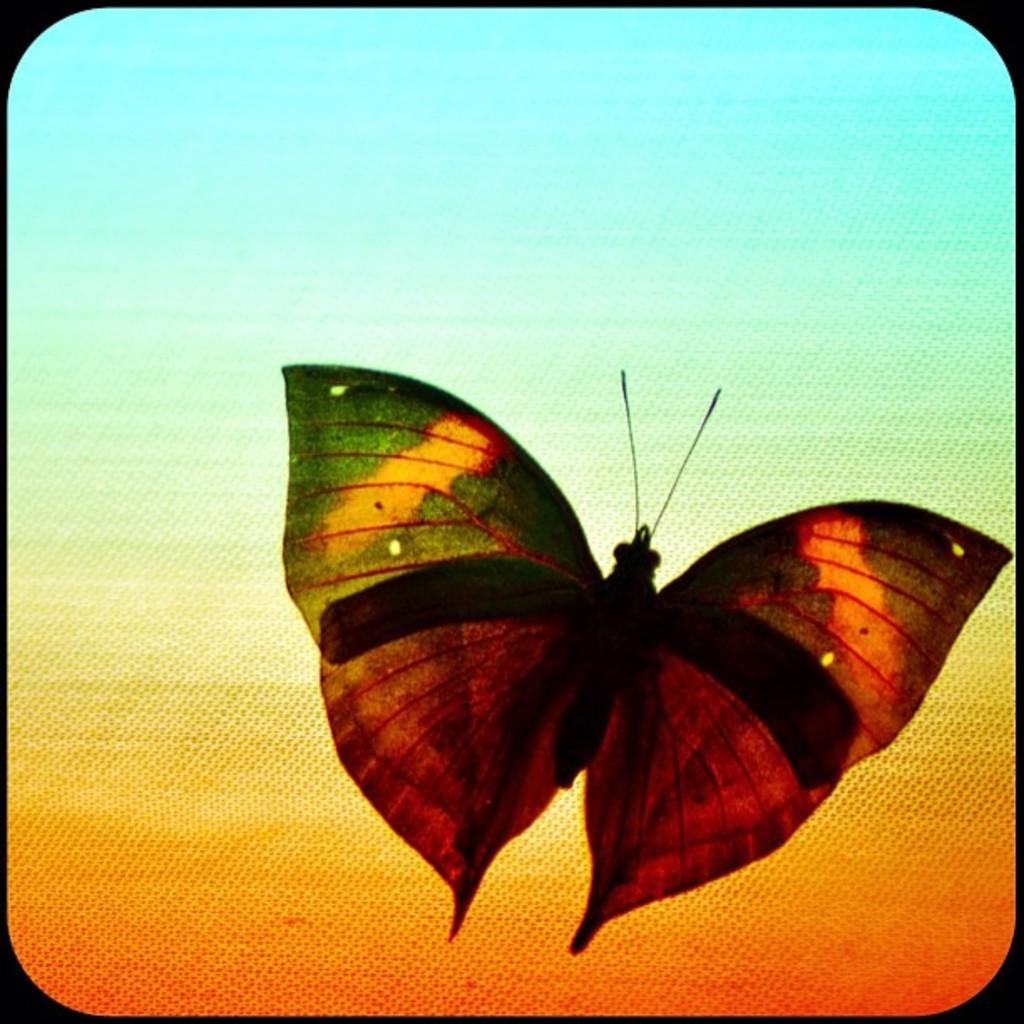What type of animal is present in the image? There is a butterfly in the image. Can you describe the appearance of the butterfly? The butterfly has different colors. What type of class does the owl attend in the image? There is no owl present in the image, so it cannot be determined if an owl attends any class. 